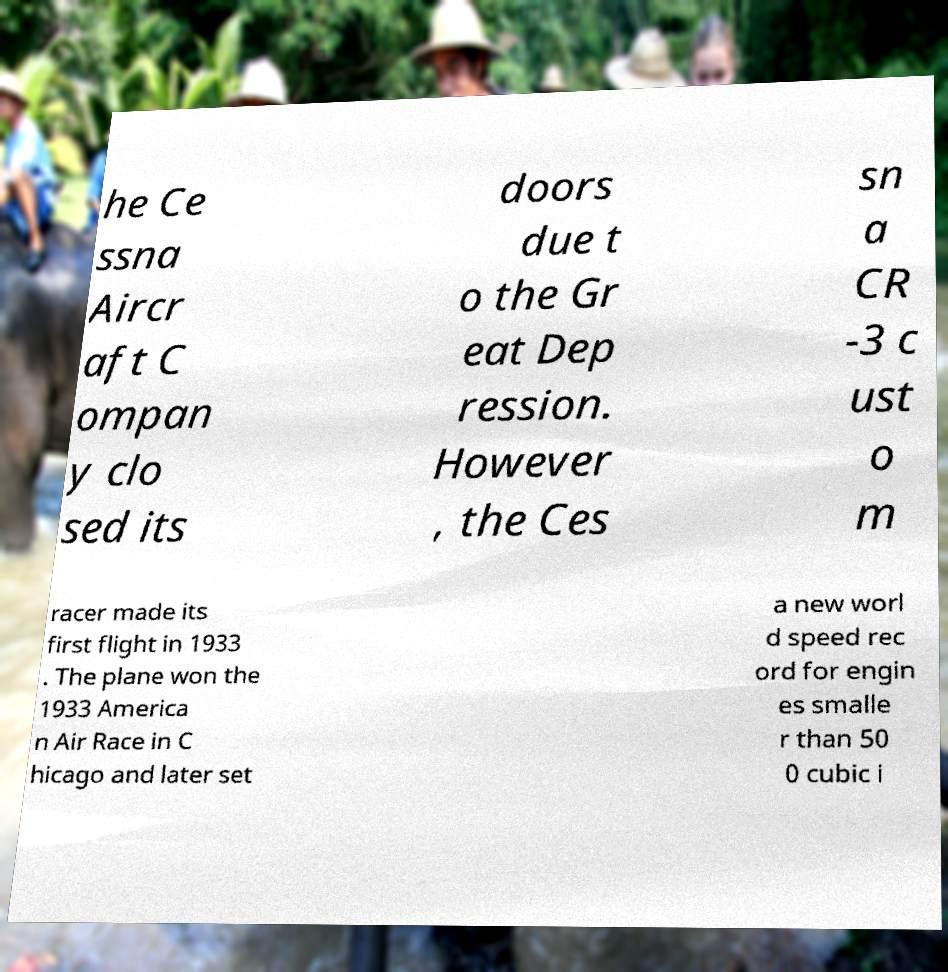There's text embedded in this image that I need extracted. Can you transcribe it verbatim? he Ce ssna Aircr aft C ompan y clo sed its doors due t o the Gr eat Dep ression. However , the Ces sn a CR -3 c ust o m racer made its first flight in 1933 . The plane won the 1933 America n Air Race in C hicago and later set a new worl d speed rec ord for engin es smalle r than 50 0 cubic i 